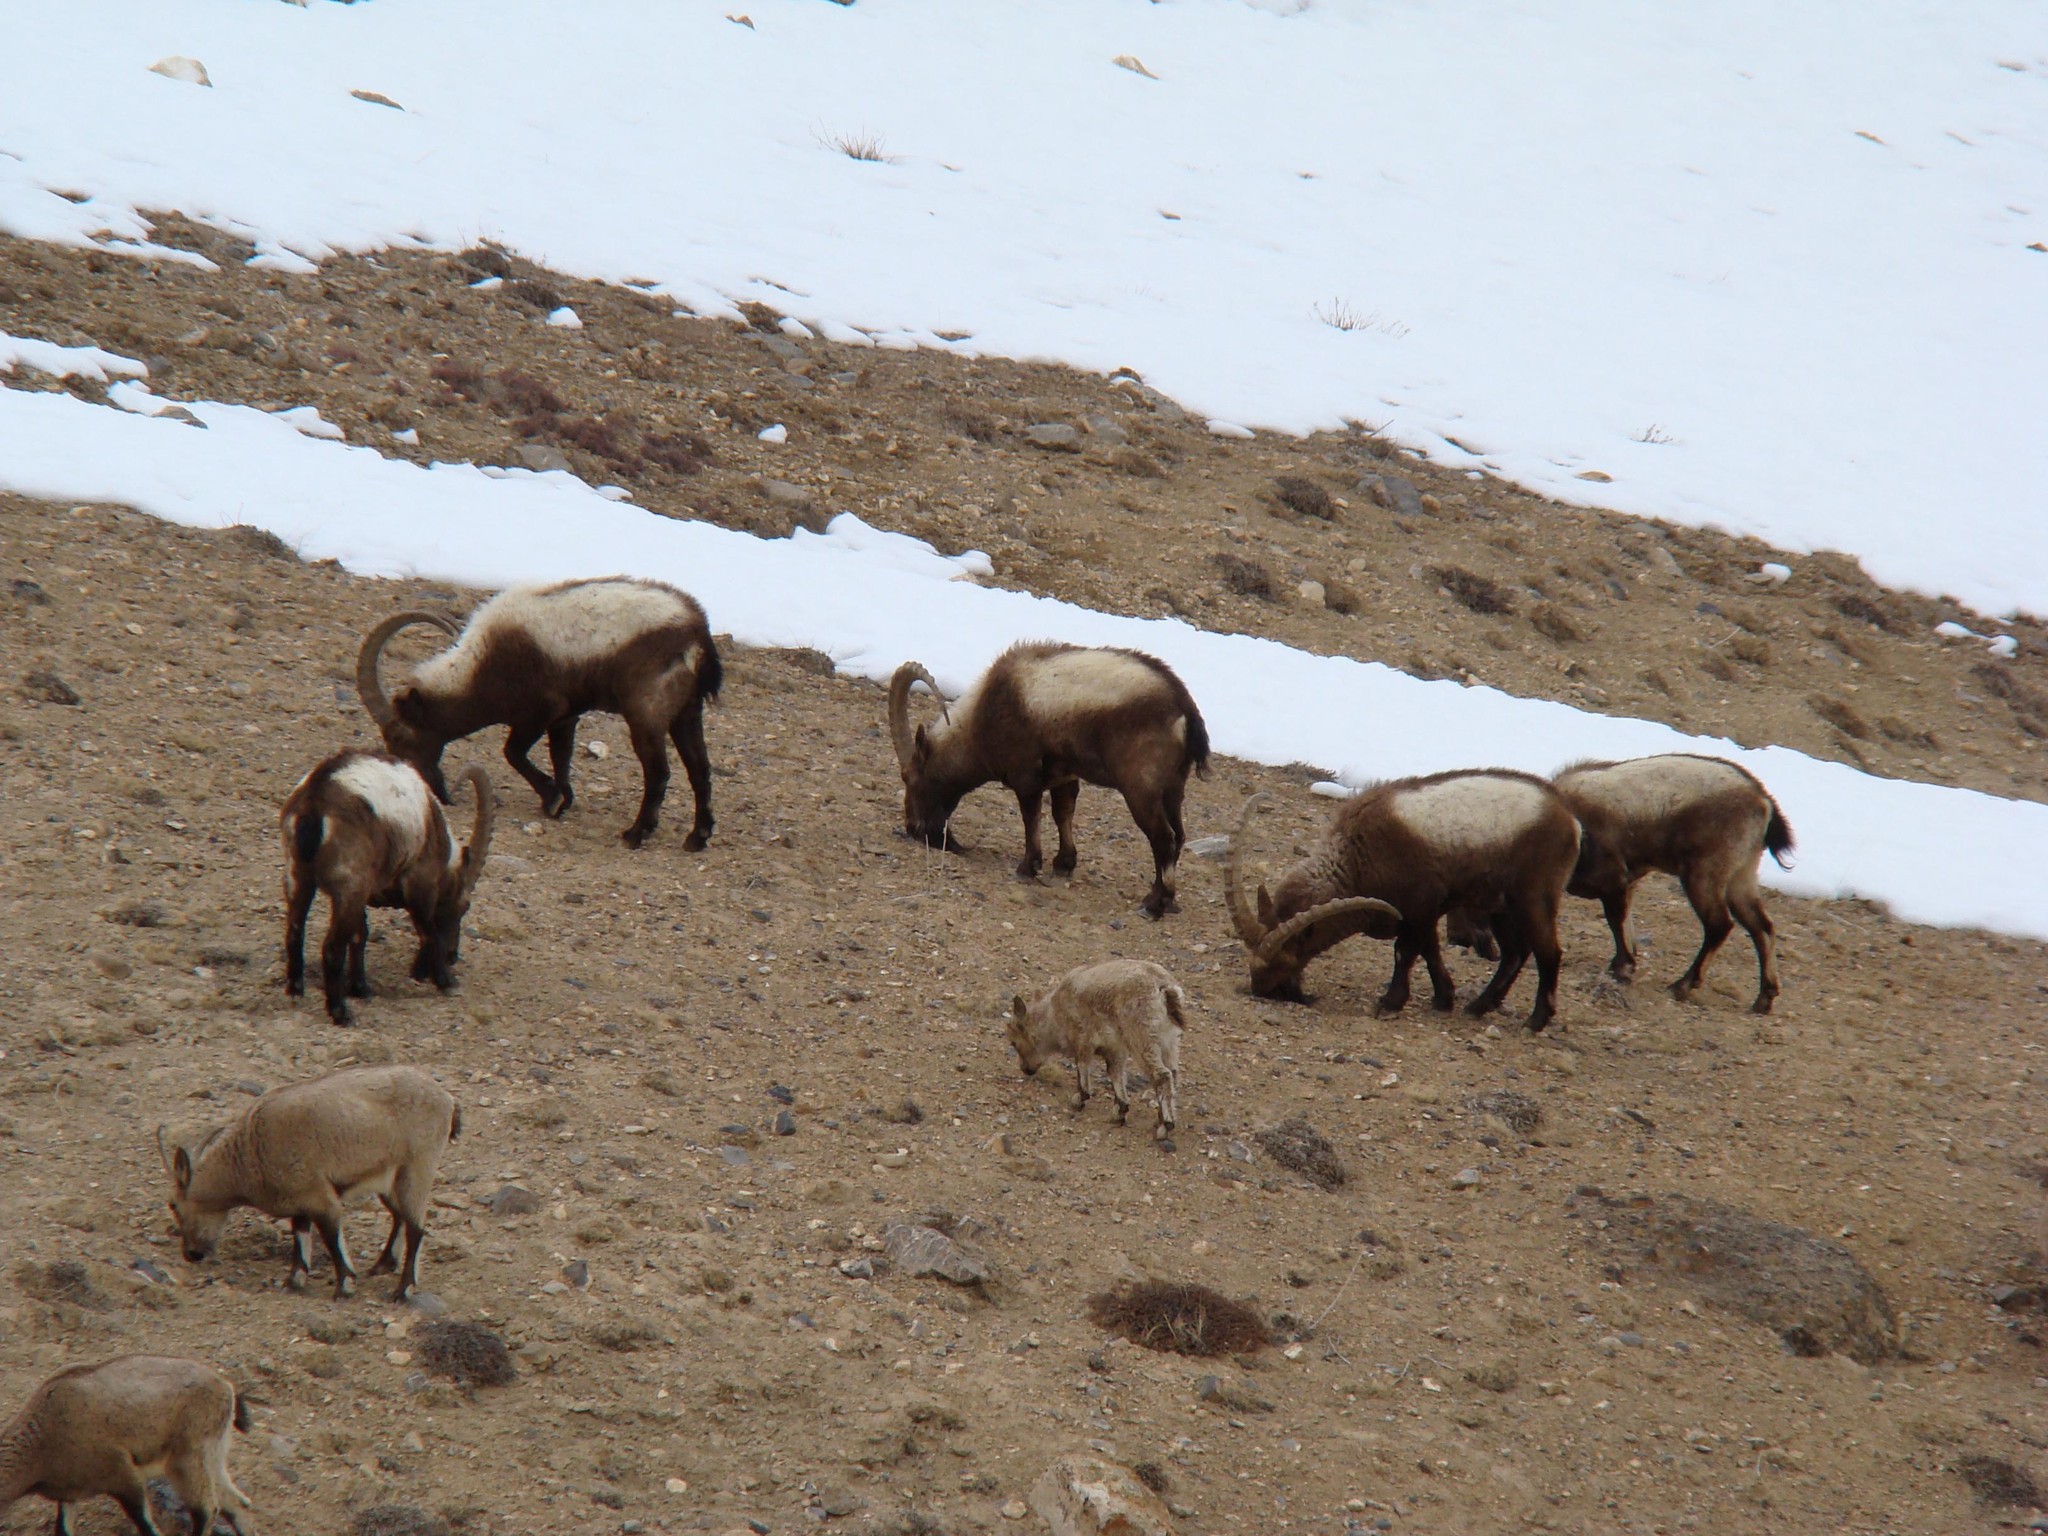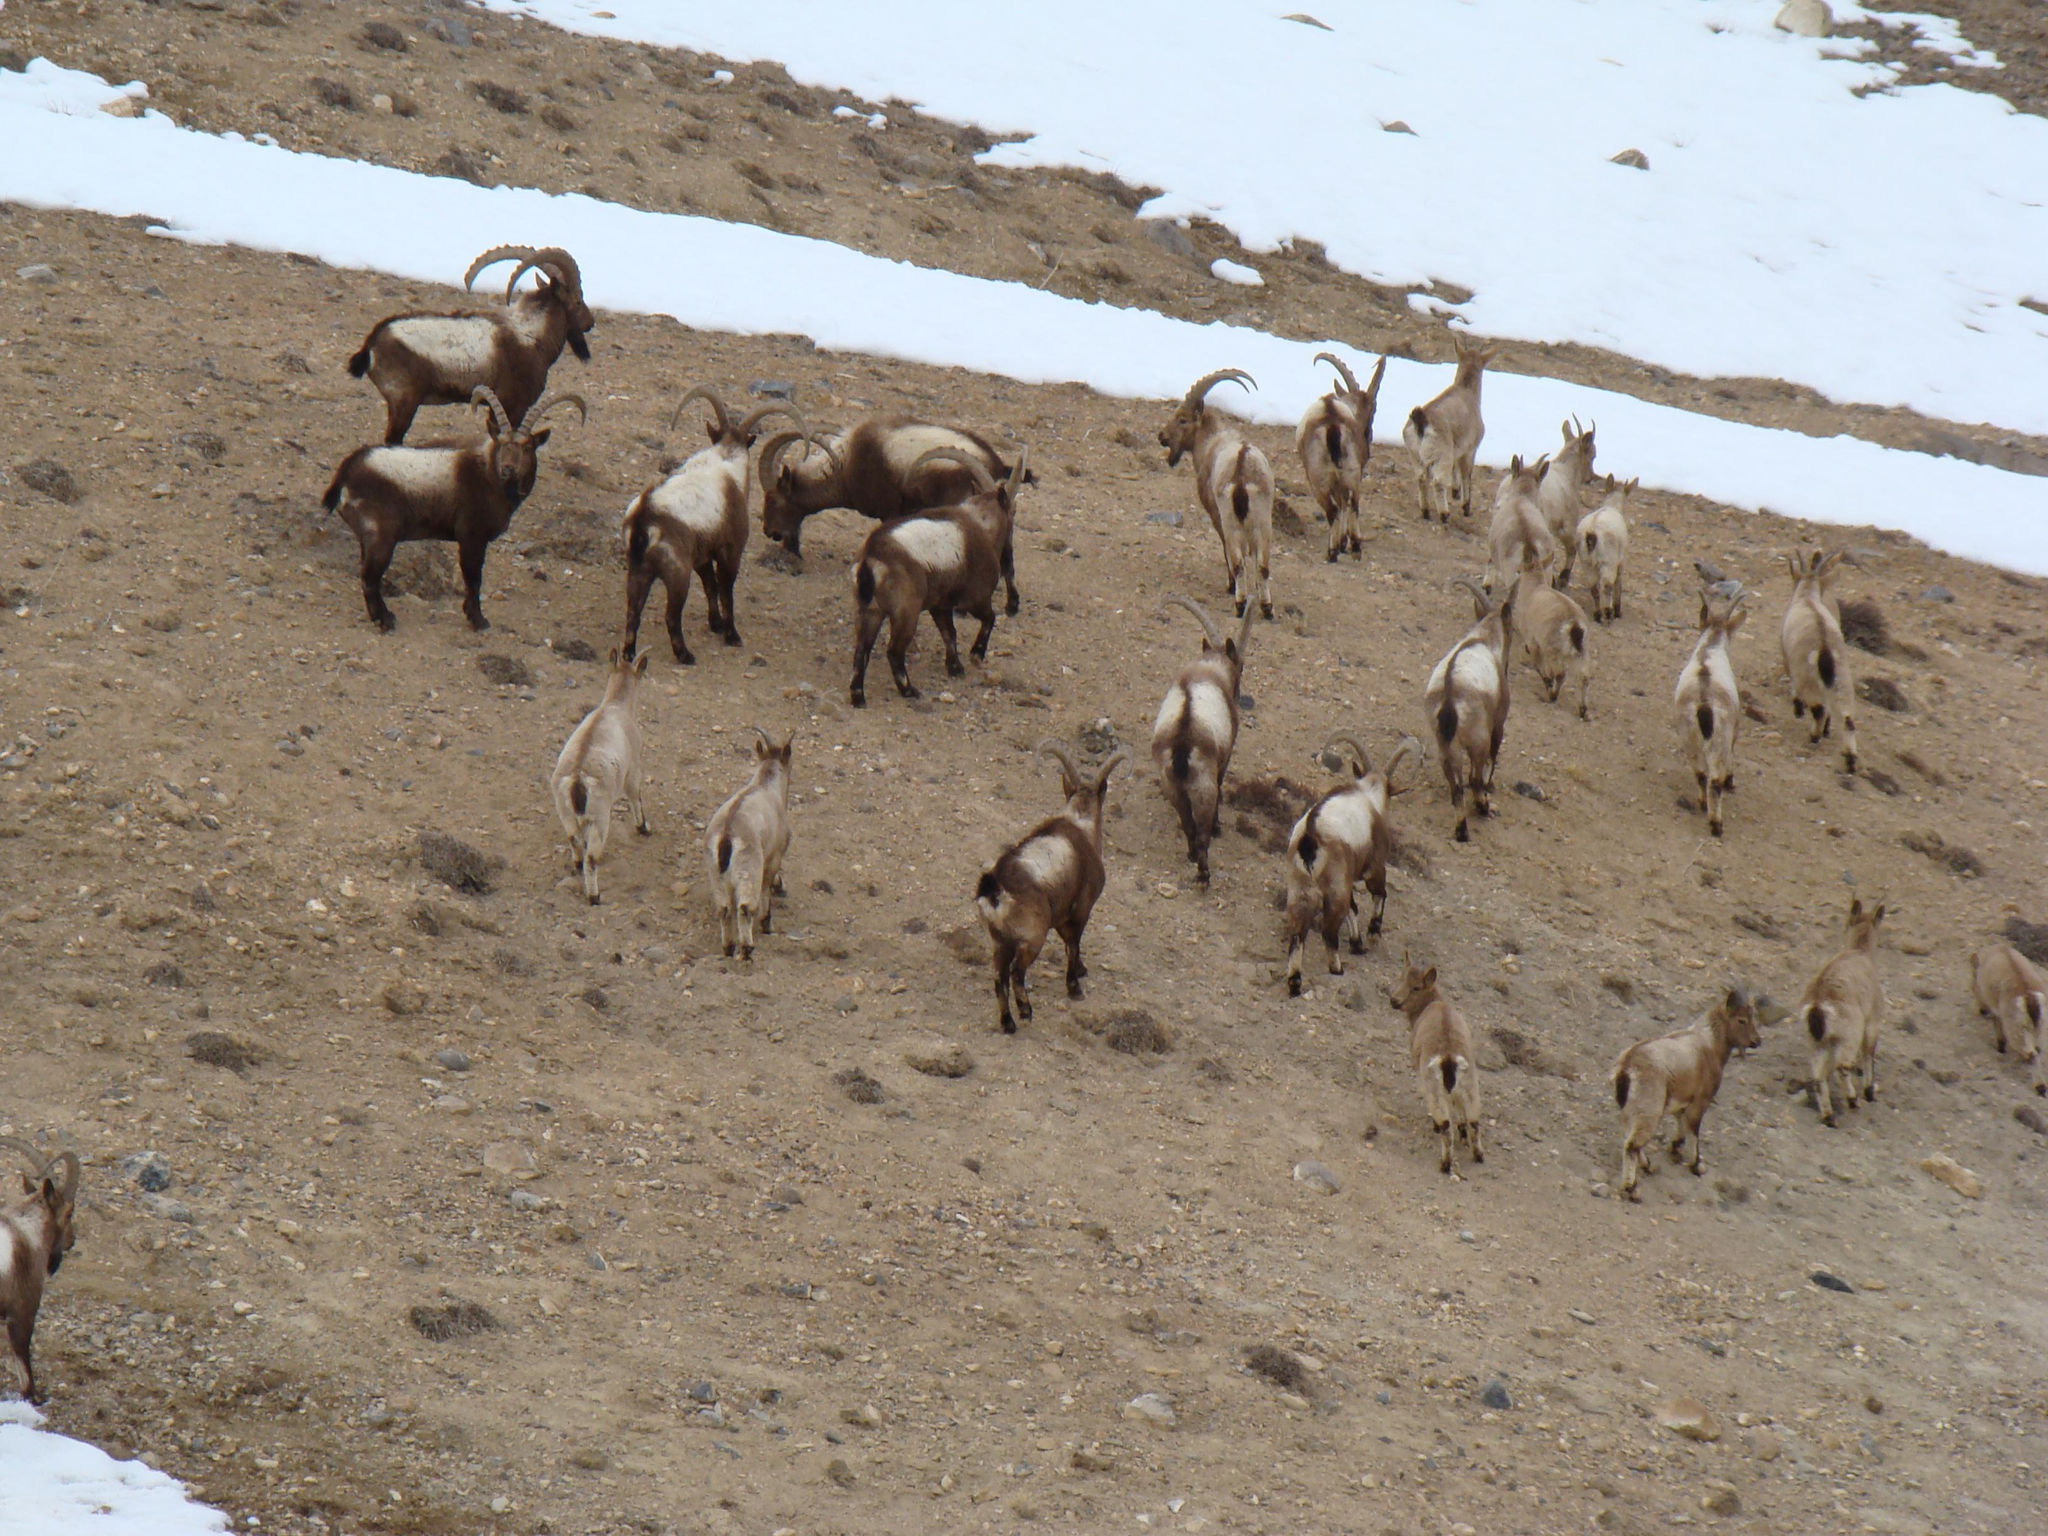The first image is the image on the left, the second image is the image on the right. Evaluate the accuracy of this statement regarding the images: "The rams are walking on green grass in the image on the left.". Is it true? Answer yes or no. No. The first image is the image on the left, the second image is the image on the right. Evaluate the accuracy of this statement regarding the images: "Right and left images contain the same number of hooved animals.". Is it true? Answer yes or no. No. 